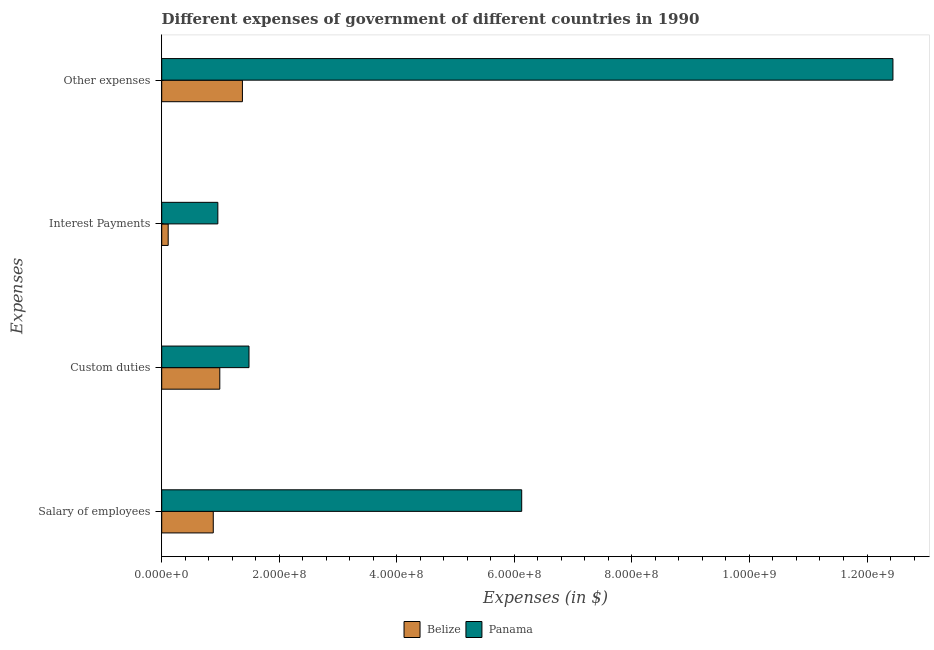How many groups of bars are there?
Provide a succinct answer. 4. Are the number of bars per tick equal to the number of legend labels?
Offer a very short reply. Yes. What is the label of the 4th group of bars from the top?
Ensure brevity in your answer.  Salary of employees. What is the amount spent on other expenses in Belize?
Give a very brief answer. 1.37e+08. Across all countries, what is the maximum amount spent on custom duties?
Provide a succinct answer. 1.48e+08. Across all countries, what is the minimum amount spent on interest payments?
Your answer should be very brief. 1.10e+07. In which country was the amount spent on salary of employees maximum?
Keep it short and to the point. Panama. In which country was the amount spent on interest payments minimum?
Your answer should be compact. Belize. What is the total amount spent on custom duties in the graph?
Ensure brevity in your answer.  2.47e+08. What is the difference between the amount spent on interest payments in Belize and that in Panama?
Offer a very short reply. -8.45e+07. What is the difference between the amount spent on custom duties in Panama and the amount spent on salary of employees in Belize?
Offer a very short reply. 6.08e+07. What is the average amount spent on interest payments per country?
Give a very brief answer. 5.33e+07. What is the difference between the amount spent on other expenses and amount spent on custom duties in Belize?
Your answer should be very brief. 3.85e+07. In how many countries, is the amount spent on other expenses greater than 600000000 $?
Provide a succinct answer. 1. What is the ratio of the amount spent on interest payments in Panama to that in Belize?
Give a very brief answer. 8.66. Is the amount spent on interest payments in Panama less than that in Belize?
Provide a short and direct response. No. Is the difference between the amount spent on salary of employees in Belize and Panama greater than the difference between the amount spent on interest payments in Belize and Panama?
Make the answer very short. No. What is the difference between the highest and the second highest amount spent on salary of employees?
Your answer should be compact. 5.25e+08. What is the difference between the highest and the lowest amount spent on interest payments?
Provide a succinct answer. 8.45e+07. In how many countries, is the amount spent on custom duties greater than the average amount spent on custom duties taken over all countries?
Make the answer very short. 1. Is the sum of the amount spent on interest payments in Belize and Panama greater than the maximum amount spent on other expenses across all countries?
Give a very brief answer. No. Is it the case that in every country, the sum of the amount spent on custom duties and amount spent on other expenses is greater than the sum of amount spent on interest payments and amount spent on salary of employees?
Provide a short and direct response. Yes. What does the 1st bar from the top in Custom duties represents?
Your response must be concise. Panama. What does the 1st bar from the bottom in Salary of employees represents?
Make the answer very short. Belize. Are all the bars in the graph horizontal?
Your answer should be compact. Yes. How many countries are there in the graph?
Your answer should be very brief. 2. What is the difference between two consecutive major ticks on the X-axis?
Make the answer very short. 2.00e+08. Are the values on the major ticks of X-axis written in scientific E-notation?
Your answer should be compact. Yes. Does the graph contain grids?
Provide a succinct answer. No. Where does the legend appear in the graph?
Your answer should be compact. Bottom center. How many legend labels are there?
Offer a terse response. 2. What is the title of the graph?
Your response must be concise. Different expenses of government of different countries in 1990. What is the label or title of the X-axis?
Keep it short and to the point. Expenses (in $). What is the label or title of the Y-axis?
Offer a very short reply. Expenses. What is the Expenses (in $) of Belize in Salary of employees?
Give a very brief answer. 8.77e+07. What is the Expenses (in $) of Panama in Salary of employees?
Ensure brevity in your answer.  6.12e+08. What is the Expenses (in $) of Belize in Custom duties?
Provide a short and direct response. 9.88e+07. What is the Expenses (in $) in Panama in Custom duties?
Your answer should be very brief. 1.48e+08. What is the Expenses (in $) in Belize in Interest Payments?
Give a very brief answer. 1.10e+07. What is the Expenses (in $) of Panama in Interest Payments?
Offer a very short reply. 9.55e+07. What is the Expenses (in $) of Belize in Other expenses?
Provide a succinct answer. 1.37e+08. What is the Expenses (in $) of Panama in Other expenses?
Make the answer very short. 1.24e+09. Across all Expenses, what is the maximum Expenses (in $) of Belize?
Offer a terse response. 1.37e+08. Across all Expenses, what is the maximum Expenses (in $) of Panama?
Your answer should be very brief. 1.24e+09. Across all Expenses, what is the minimum Expenses (in $) of Belize?
Make the answer very short. 1.10e+07. Across all Expenses, what is the minimum Expenses (in $) in Panama?
Provide a succinct answer. 9.55e+07. What is the total Expenses (in $) of Belize in the graph?
Make the answer very short. 3.35e+08. What is the total Expenses (in $) of Panama in the graph?
Offer a terse response. 2.10e+09. What is the difference between the Expenses (in $) in Belize in Salary of employees and that in Custom duties?
Your answer should be compact. -1.11e+07. What is the difference between the Expenses (in $) of Panama in Salary of employees and that in Custom duties?
Offer a very short reply. 4.64e+08. What is the difference between the Expenses (in $) of Belize in Salary of employees and that in Interest Payments?
Provide a succinct answer. 7.67e+07. What is the difference between the Expenses (in $) in Panama in Salary of employees and that in Interest Payments?
Offer a terse response. 5.17e+08. What is the difference between the Expenses (in $) of Belize in Salary of employees and that in Other expenses?
Make the answer very short. -4.96e+07. What is the difference between the Expenses (in $) in Panama in Salary of employees and that in Other expenses?
Give a very brief answer. -6.32e+08. What is the difference between the Expenses (in $) of Belize in Custom duties and that in Interest Payments?
Offer a very short reply. 8.78e+07. What is the difference between the Expenses (in $) in Panama in Custom duties and that in Interest Payments?
Offer a terse response. 5.30e+07. What is the difference between the Expenses (in $) of Belize in Custom duties and that in Other expenses?
Give a very brief answer. -3.85e+07. What is the difference between the Expenses (in $) of Panama in Custom duties and that in Other expenses?
Offer a terse response. -1.10e+09. What is the difference between the Expenses (in $) in Belize in Interest Payments and that in Other expenses?
Keep it short and to the point. -1.26e+08. What is the difference between the Expenses (in $) of Panama in Interest Payments and that in Other expenses?
Give a very brief answer. -1.15e+09. What is the difference between the Expenses (in $) in Belize in Salary of employees and the Expenses (in $) in Panama in Custom duties?
Provide a succinct answer. -6.08e+07. What is the difference between the Expenses (in $) of Belize in Salary of employees and the Expenses (in $) of Panama in Interest Payments?
Offer a very short reply. -7.78e+06. What is the difference between the Expenses (in $) of Belize in Salary of employees and the Expenses (in $) of Panama in Other expenses?
Ensure brevity in your answer.  -1.16e+09. What is the difference between the Expenses (in $) of Belize in Custom duties and the Expenses (in $) of Panama in Interest Payments?
Offer a very short reply. 3.33e+06. What is the difference between the Expenses (in $) in Belize in Custom duties and the Expenses (in $) in Panama in Other expenses?
Your answer should be very brief. -1.15e+09. What is the difference between the Expenses (in $) of Belize in Interest Payments and the Expenses (in $) of Panama in Other expenses?
Give a very brief answer. -1.23e+09. What is the average Expenses (in $) of Belize per Expenses?
Give a very brief answer. 8.37e+07. What is the average Expenses (in $) in Panama per Expenses?
Your answer should be very brief. 5.25e+08. What is the difference between the Expenses (in $) in Belize and Expenses (in $) in Panama in Salary of employees?
Your answer should be very brief. -5.25e+08. What is the difference between the Expenses (in $) of Belize and Expenses (in $) of Panama in Custom duties?
Give a very brief answer. -4.97e+07. What is the difference between the Expenses (in $) of Belize and Expenses (in $) of Panama in Interest Payments?
Offer a very short reply. -8.45e+07. What is the difference between the Expenses (in $) of Belize and Expenses (in $) of Panama in Other expenses?
Keep it short and to the point. -1.11e+09. What is the ratio of the Expenses (in $) of Belize in Salary of employees to that in Custom duties?
Keep it short and to the point. 0.89. What is the ratio of the Expenses (in $) in Panama in Salary of employees to that in Custom duties?
Give a very brief answer. 4.12. What is the ratio of the Expenses (in $) of Belize in Salary of employees to that in Interest Payments?
Ensure brevity in your answer.  7.96. What is the ratio of the Expenses (in $) in Panama in Salary of employees to that in Interest Payments?
Make the answer very short. 6.41. What is the ratio of the Expenses (in $) in Belize in Salary of employees to that in Other expenses?
Ensure brevity in your answer.  0.64. What is the ratio of the Expenses (in $) in Panama in Salary of employees to that in Other expenses?
Your answer should be very brief. 0.49. What is the ratio of the Expenses (in $) of Belize in Custom duties to that in Interest Payments?
Offer a very short reply. 8.97. What is the ratio of the Expenses (in $) in Panama in Custom duties to that in Interest Payments?
Your answer should be very brief. 1.55. What is the ratio of the Expenses (in $) of Belize in Custom duties to that in Other expenses?
Your answer should be very brief. 0.72. What is the ratio of the Expenses (in $) of Panama in Custom duties to that in Other expenses?
Make the answer very short. 0.12. What is the ratio of the Expenses (in $) of Belize in Interest Payments to that in Other expenses?
Provide a succinct answer. 0.08. What is the ratio of the Expenses (in $) in Panama in Interest Payments to that in Other expenses?
Ensure brevity in your answer.  0.08. What is the difference between the highest and the second highest Expenses (in $) in Belize?
Offer a very short reply. 3.85e+07. What is the difference between the highest and the second highest Expenses (in $) in Panama?
Offer a terse response. 6.32e+08. What is the difference between the highest and the lowest Expenses (in $) of Belize?
Your answer should be very brief. 1.26e+08. What is the difference between the highest and the lowest Expenses (in $) of Panama?
Keep it short and to the point. 1.15e+09. 